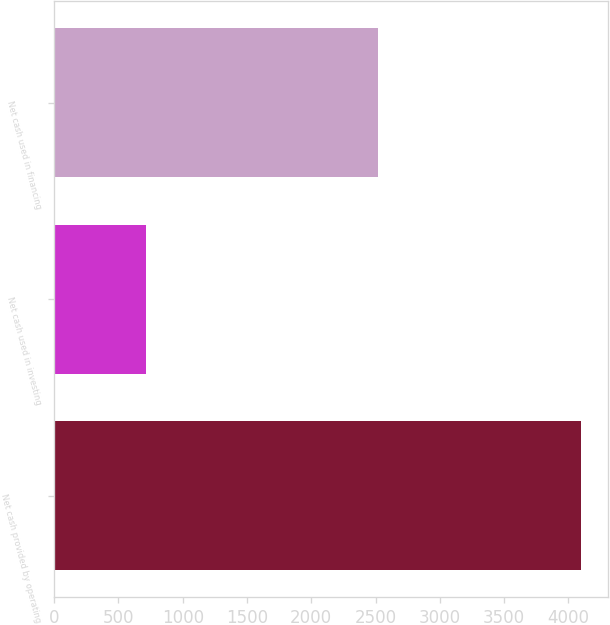<chart> <loc_0><loc_0><loc_500><loc_500><bar_chart><fcel>Net cash provided by operating<fcel>Net cash used in investing<fcel>Net cash used in financing<nl><fcel>4101<fcel>715<fcel>2516<nl></chart> 